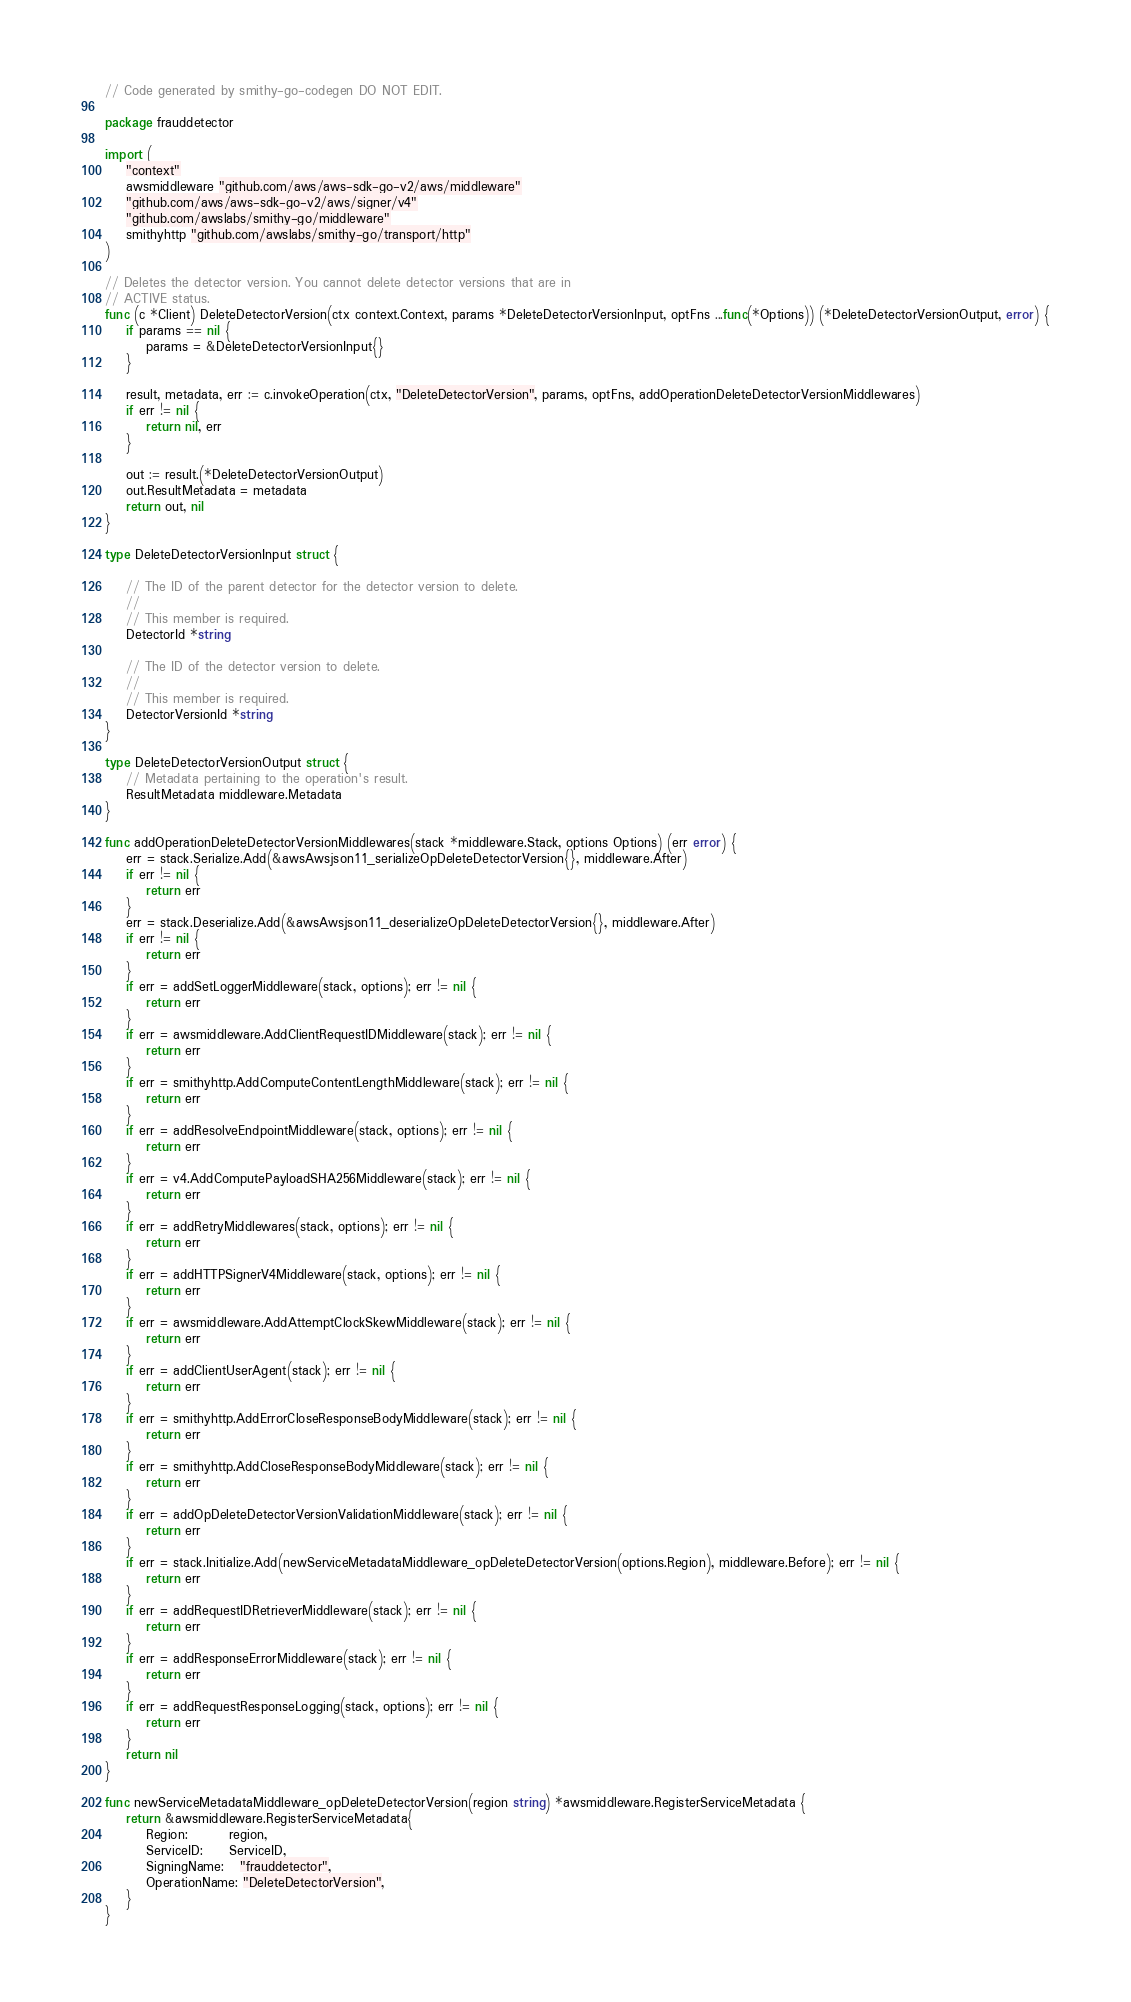Convert code to text. <code><loc_0><loc_0><loc_500><loc_500><_Go_>// Code generated by smithy-go-codegen DO NOT EDIT.

package frauddetector

import (
	"context"
	awsmiddleware "github.com/aws/aws-sdk-go-v2/aws/middleware"
	"github.com/aws/aws-sdk-go-v2/aws/signer/v4"
	"github.com/awslabs/smithy-go/middleware"
	smithyhttp "github.com/awslabs/smithy-go/transport/http"
)

// Deletes the detector version. You cannot delete detector versions that are in
// ACTIVE status.
func (c *Client) DeleteDetectorVersion(ctx context.Context, params *DeleteDetectorVersionInput, optFns ...func(*Options)) (*DeleteDetectorVersionOutput, error) {
	if params == nil {
		params = &DeleteDetectorVersionInput{}
	}

	result, metadata, err := c.invokeOperation(ctx, "DeleteDetectorVersion", params, optFns, addOperationDeleteDetectorVersionMiddlewares)
	if err != nil {
		return nil, err
	}

	out := result.(*DeleteDetectorVersionOutput)
	out.ResultMetadata = metadata
	return out, nil
}

type DeleteDetectorVersionInput struct {

	// The ID of the parent detector for the detector version to delete.
	//
	// This member is required.
	DetectorId *string

	// The ID of the detector version to delete.
	//
	// This member is required.
	DetectorVersionId *string
}

type DeleteDetectorVersionOutput struct {
	// Metadata pertaining to the operation's result.
	ResultMetadata middleware.Metadata
}

func addOperationDeleteDetectorVersionMiddlewares(stack *middleware.Stack, options Options) (err error) {
	err = stack.Serialize.Add(&awsAwsjson11_serializeOpDeleteDetectorVersion{}, middleware.After)
	if err != nil {
		return err
	}
	err = stack.Deserialize.Add(&awsAwsjson11_deserializeOpDeleteDetectorVersion{}, middleware.After)
	if err != nil {
		return err
	}
	if err = addSetLoggerMiddleware(stack, options); err != nil {
		return err
	}
	if err = awsmiddleware.AddClientRequestIDMiddleware(stack); err != nil {
		return err
	}
	if err = smithyhttp.AddComputeContentLengthMiddleware(stack); err != nil {
		return err
	}
	if err = addResolveEndpointMiddleware(stack, options); err != nil {
		return err
	}
	if err = v4.AddComputePayloadSHA256Middleware(stack); err != nil {
		return err
	}
	if err = addRetryMiddlewares(stack, options); err != nil {
		return err
	}
	if err = addHTTPSignerV4Middleware(stack, options); err != nil {
		return err
	}
	if err = awsmiddleware.AddAttemptClockSkewMiddleware(stack); err != nil {
		return err
	}
	if err = addClientUserAgent(stack); err != nil {
		return err
	}
	if err = smithyhttp.AddErrorCloseResponseBodyMiddleware(stack); err != nil {
		return err
	}
	if err = smithyhttp.AddCloseResponseBodyMiddleware(stack); err != nil {
		return err
	}
	if err = addOpDeleteDetectorVersionValidationMiddleware(stack); err != nil {
		return err
	}
	if err = stack.Initialize.Add(newServiceMetadataMiddleware_opDeleteDetectorVersion(options.Region), middleware.Before); err != nil {
		return err
	}
	if err = addRequestIDRetrieverMiddleware(stack); err != nil {
		return err
	}
	if err = addResponseErrorMiddleware(stack); err != nil {
		return err
	}
	if err = addRequestResponseLogging(stack, options); err != nil {
		return err
	}
	return nil
}

func newServiceMetadataMiddleware_opDeleteDetectorVersion(region string) *awsmiddleware.RegisterServiceMetadata {
	return &awsmiddleware.RegisterServiceMetadata{
		Region:        region,
		ServiceID:     ServiceID,
		SigningName:   "frauddetector",
		OperationName: "DeleteDetectorVersion",
	}
}
</code> 